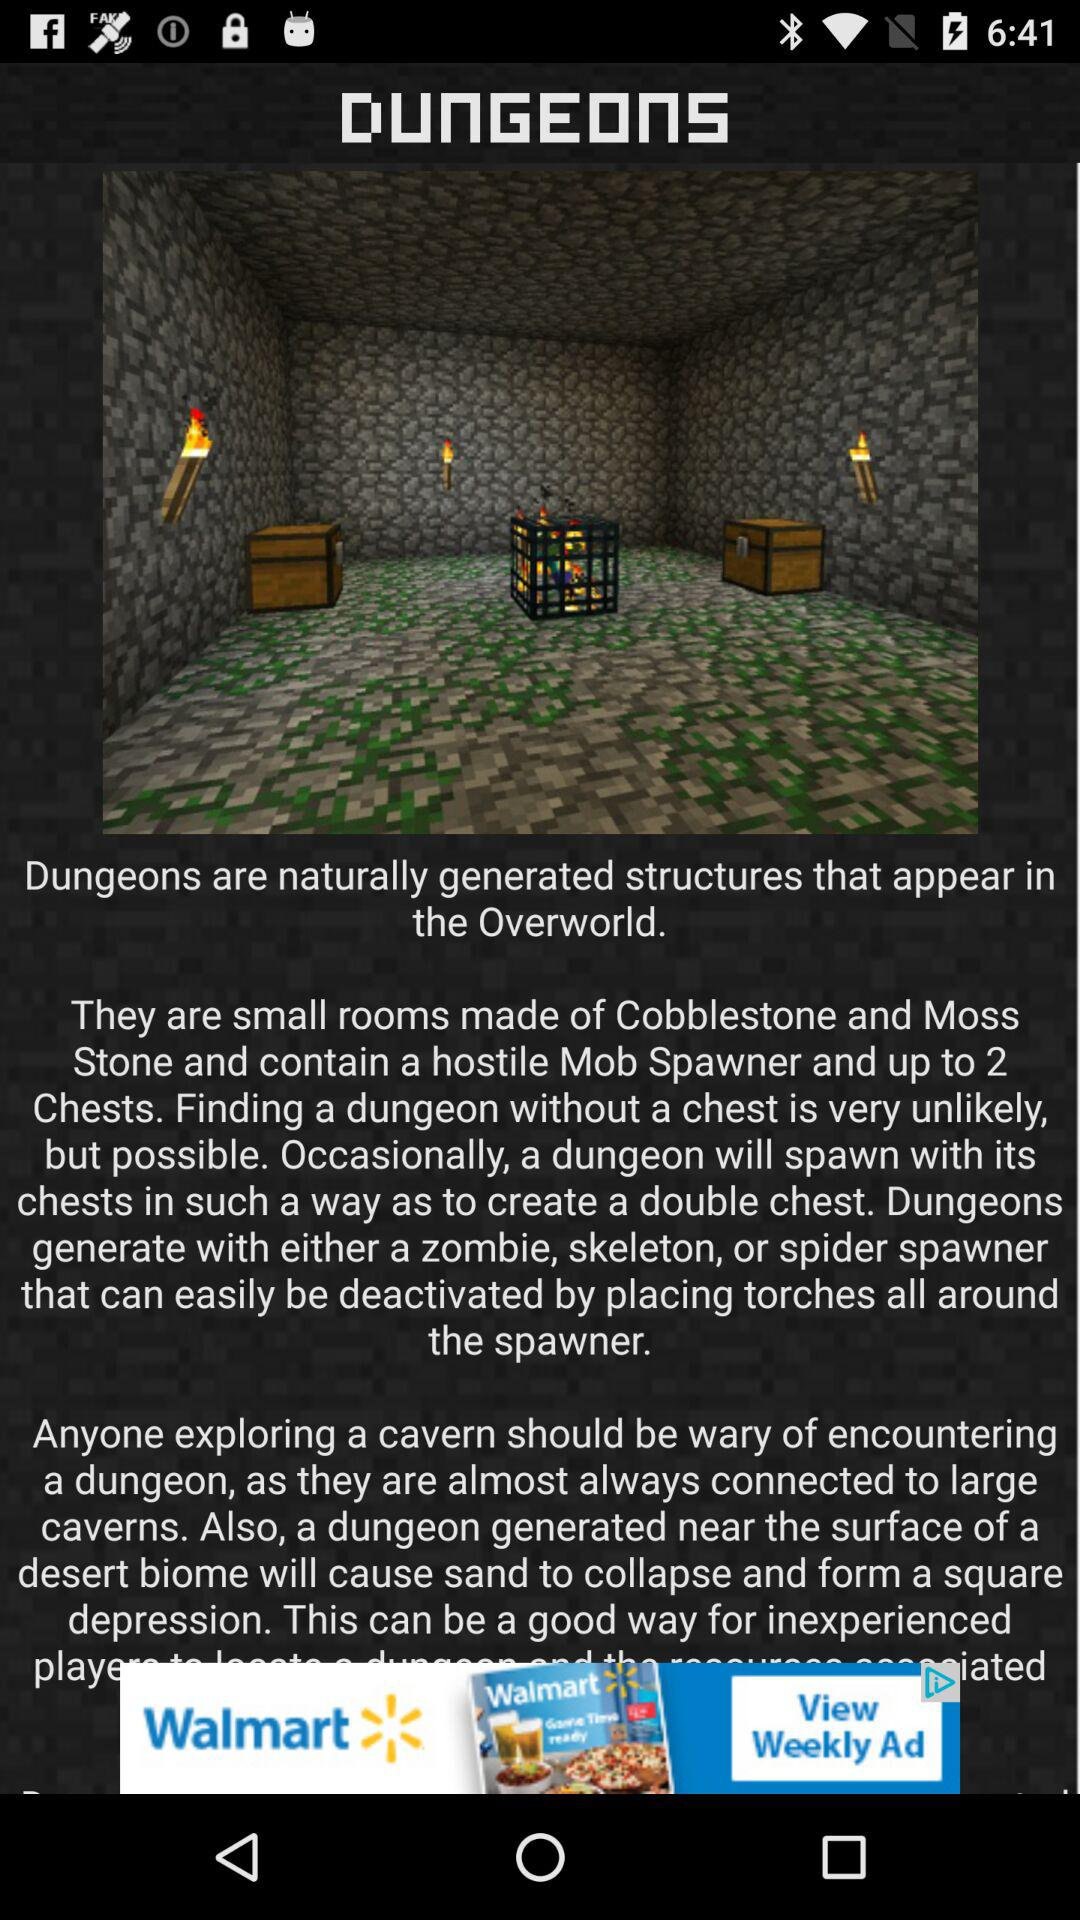How many more chests can a dungeon have than mobs?
Answer the question using a single word or phrase. 1 